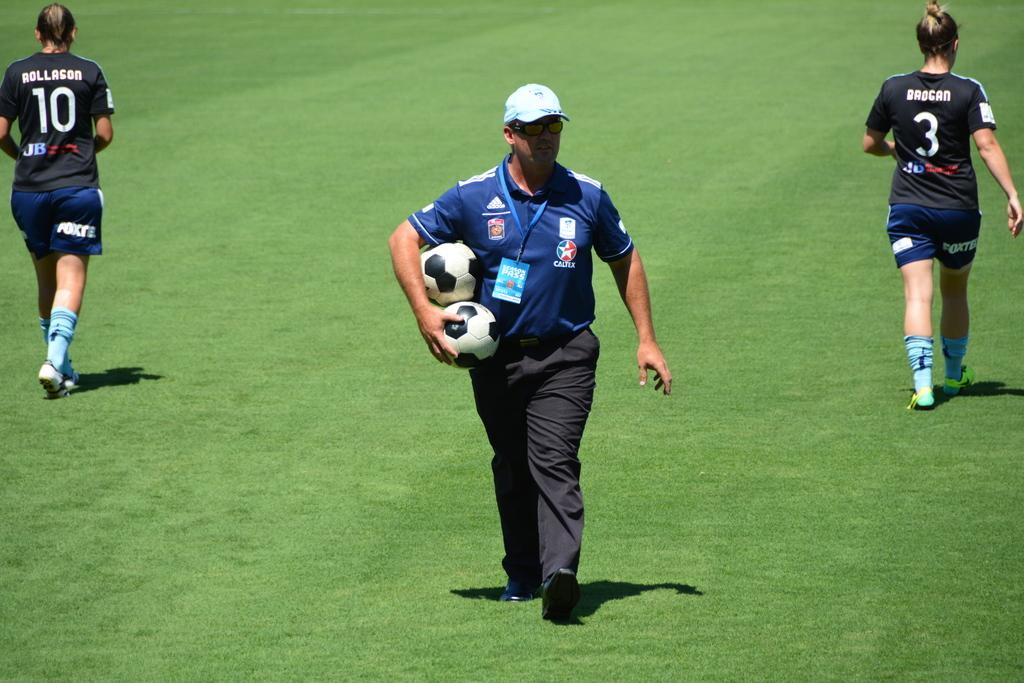What is the surface that the people are standing on in the image? The ground is covered with grass. What are the people doing in the image? The people are standing on the ground. What is the man in the middle holding in his hand? The man in the middle is holding balls in his hand. What type of sand can be seen on the man's tongue in the image? There is no sand or man's tongue present in the image; it features people standing on grass-covered ground with a man holding balls in his hand. 